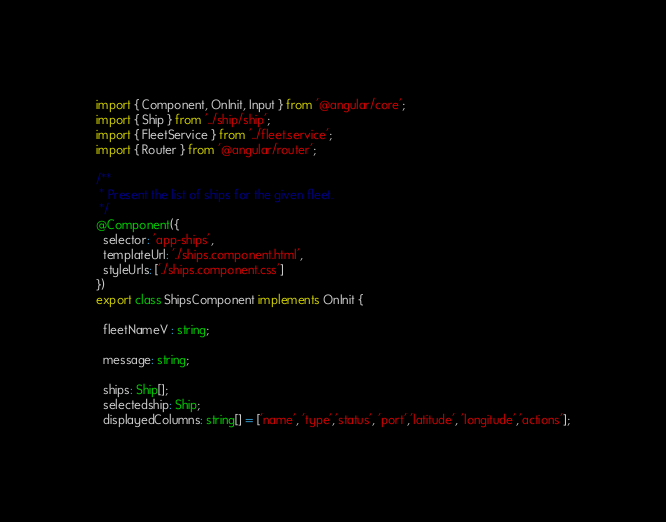<code> <loc_0><loc_0><loc_500><loc_500><_TypeScript_>import { Component, OnInit, Input } from '@angular/core';
import { Ship } from '../ship/ship';
import { FleetService } from '../fleet.service';
import { Router } from '@angular/router';

/**
 * Present the list of ships for the given fleet.
 */
@Component({
  selector: 'app-ships',
  templateUrl: './ships.component.html',
  styleUrls: ['./ships.component.css']
})
export class ShipsComponent implements OnInit {

  fleetNameV : string;

  message: string;
  
  ships: Ship[];
  selectedship: Ship;
  displayedColumns: string[] = ['name', 'type','status', 'port','latitude', 'longitude','actions'];
</code> 